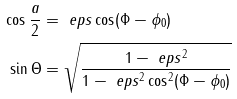<formula> <loc_0><loc_0><loc_500><loc_500>\cos \frac { a } { 2 } & = \ e p s \cos ( \Phi - \phi _ { 0 } ) \\ \sin \Theta & = \sqrt { \frac { 1 - \ e p s ^ { 2 } } { 1 - \ e p s ^ { 2 } \cos ^ { 2 } ( \Phi - \phi _ { 0 } ) } }</formula> 